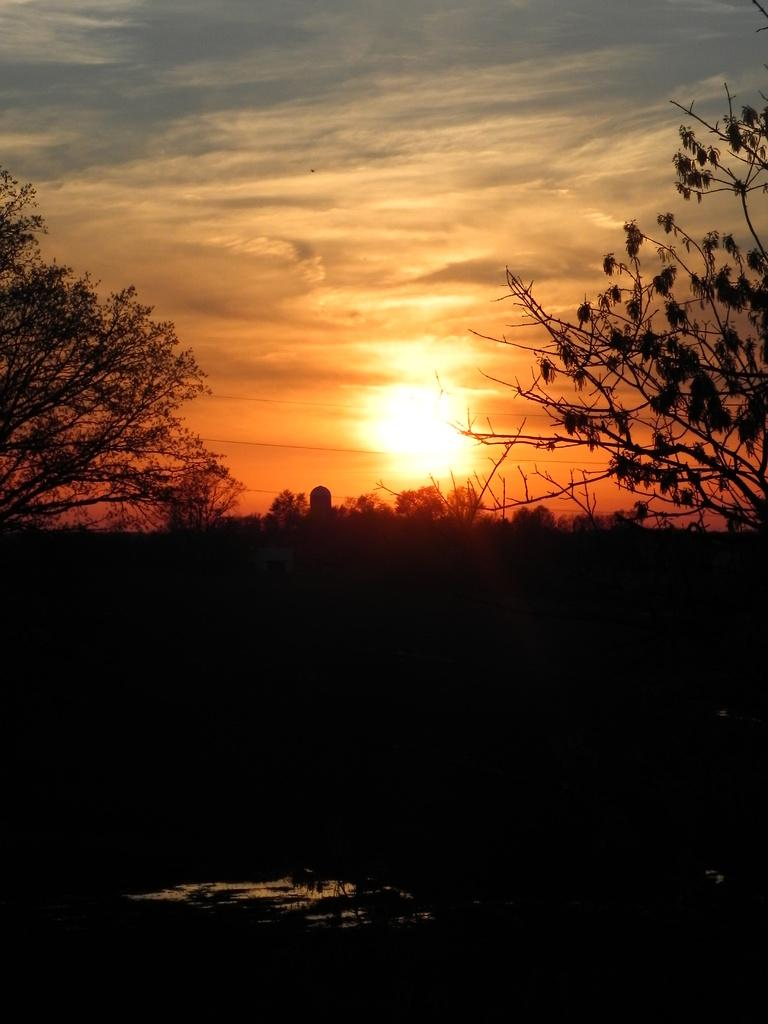What is located in the center of the image? There are trees in the center of the image. What can be seen at the bottom of the image? There is water at the bottom of the image. Are there any trees on the right side of the image? Yes, there are trees on the right side of the image. Are there any trees on the left side of the image? Yes, there are trees on the left side of the image. What is visible at the top of the image? The sky is visible at the top of the image. How many mice can be seen swimming in the water at the bottom of the image? There are no mice present in the image; it features trees and water. What type of basin is used to collect the water at the bottom of the image? There is no basin present in the image; it is a natural body of water. 